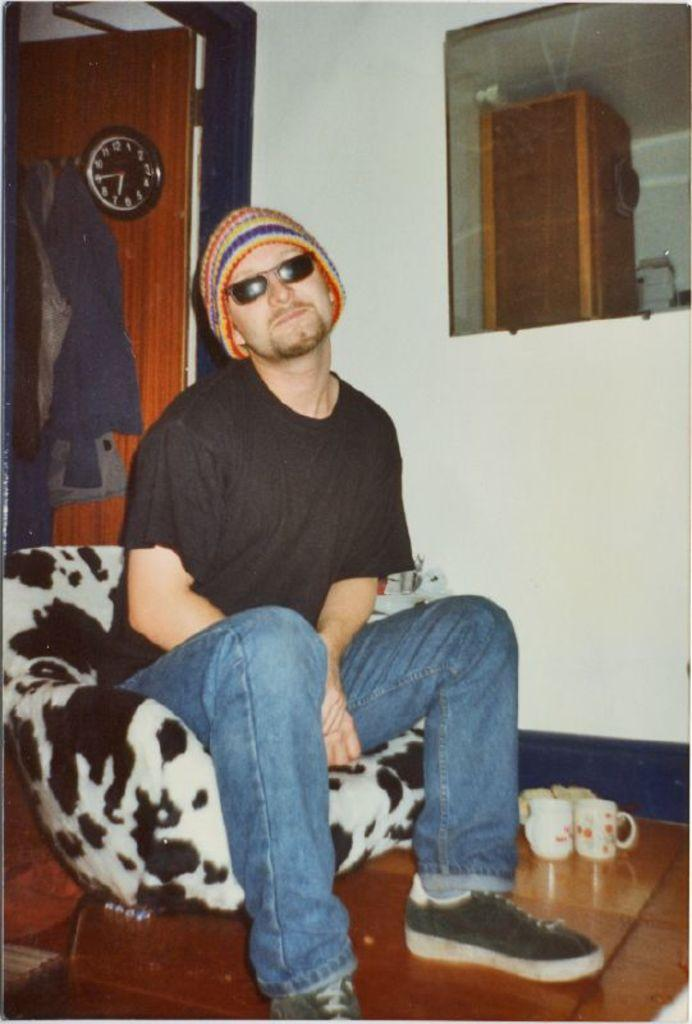What is the man in the image doing? The man is seated on a chair in the image. What objects can be seen near the man? There are cups visible in the image. What can be seen in the background of the image? There is a clock and a mirror in the background of the image. What type of pot is being used by the passenger in the image? There is no passenger or pot present in the image. How many nails can be seen in the image? There are no nails visible in the image. 